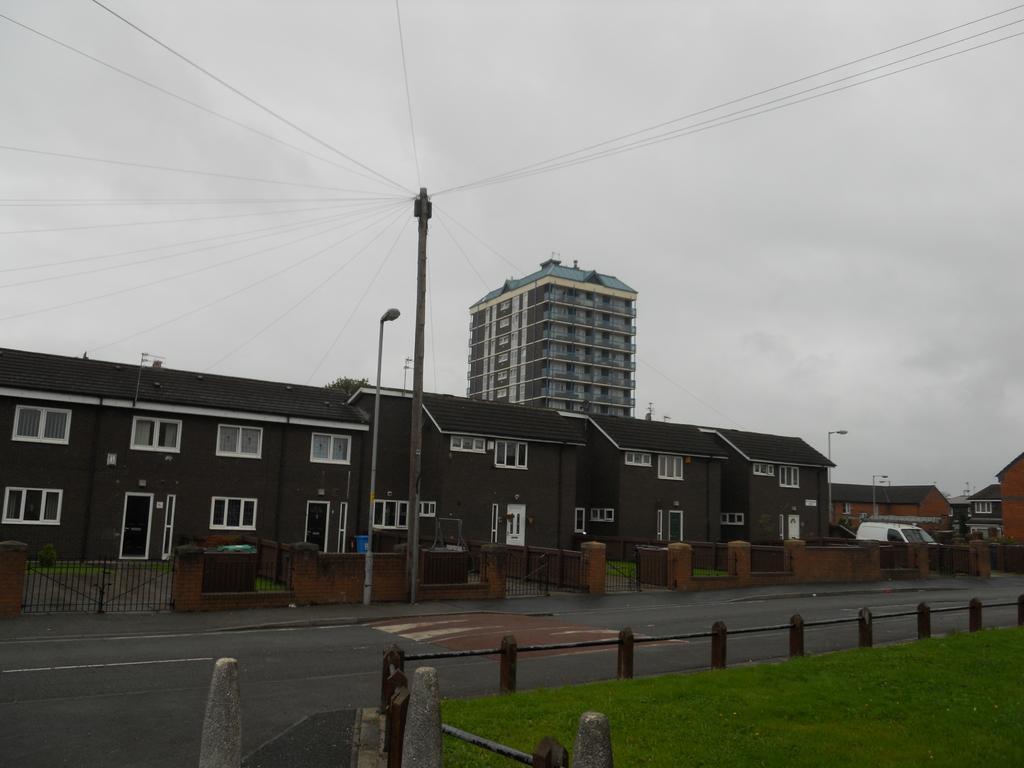Could you give a brief overview of what you see in this image? In the picture we can see buildings with doors and windows and around the buildings we can see walls and gates and near the buildings we can see a pole with light and to the opposite side we can see a railing and behind it we can see a grass surface and in the background we can see a tower building with many floors and behind it we can see a sky with clouds. 